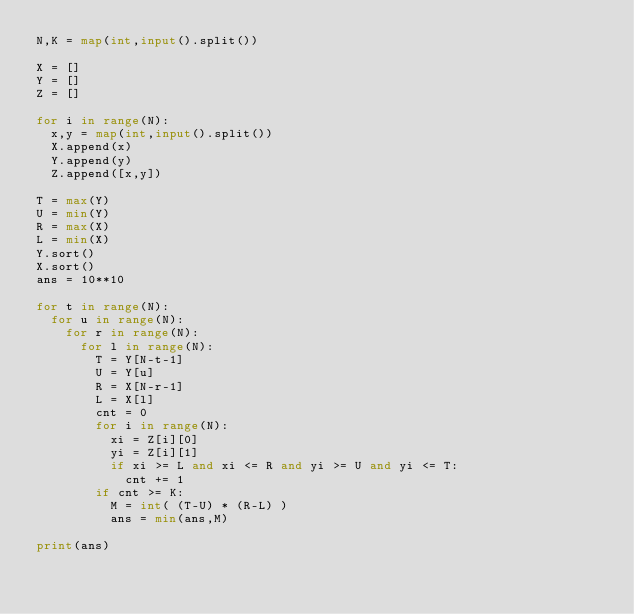Convert code to text. <code><loc_0><loc_0><loc_500><loc_500><_Python_>N,K = map(int,input().split())

X = []
Y = []
Z = []

for i in range(N):
  x,y = map(int,input().split())
  X.append(x)
  Y.append(y)
  Z.append([x,y])
  
T = max(Y)
U = min(Y)
R = max(X)
L = min(X)
Y.sort()
X.sort()
ans = 10**10

for t in range(N):
  for u in range(N):
    for r in range(N):
      for l in range(N):
        T = Y[N-t-1]
        U = Y[u]
        R = X[N-r-1]
        L = X[l]
        cnt = 0
        for i in range(N):
          xi = Z[i][0]
          yi = Z[i][1]
          if xi >= L and xi <= R and yi >= U and yi <= T:
            cnt += 1
        if cnt >= K:
          M = int( (T-U) * (R-L) )
          ans = min(ans,M)
          
print(ans)</code> 